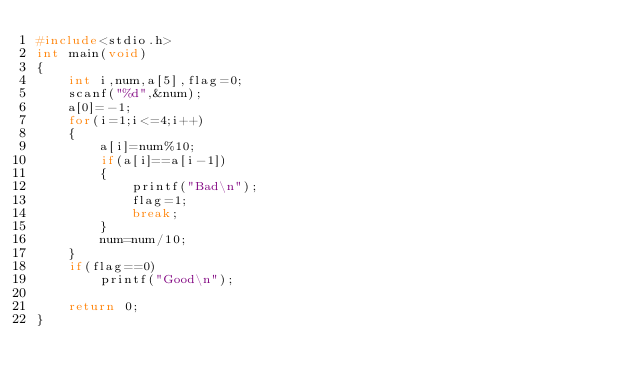<code> <loc_0><loc_0><loc_500><loc_500><_C++_>#include<stdio.h>
int main(void)
{
	int i,num,a[5],flag=0;
	scanf("%d",&num);
	a[0]=-1;
	for(i=1;i<=4;i++)
	{
		a[i]=num%10;
		if(a[i]==a[i-1])
		{
			printf("Bad\n");
			flag=1;
			break;
		}
		num=num/10;
	}
	if(flag==0)
		printf("Good\n");

	return 0;
}
</code> 